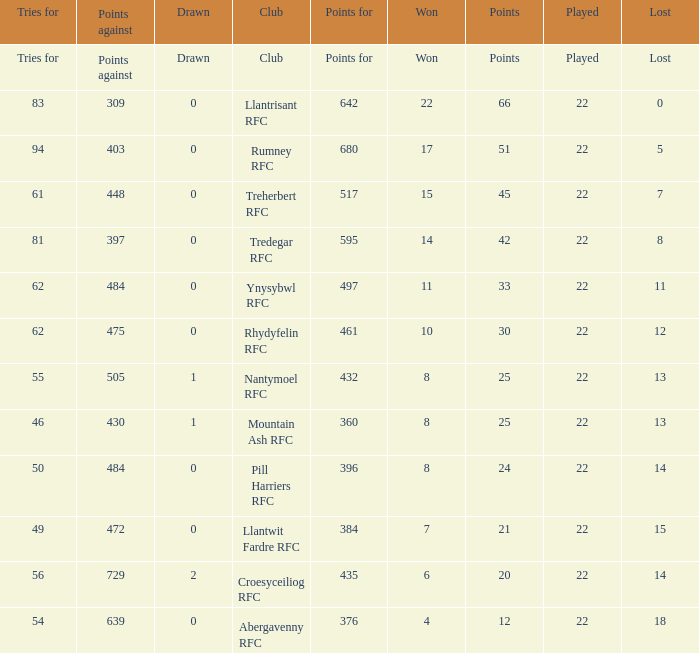How many matches were won by the teams that scored exactly 61 tries for? 15.0. 